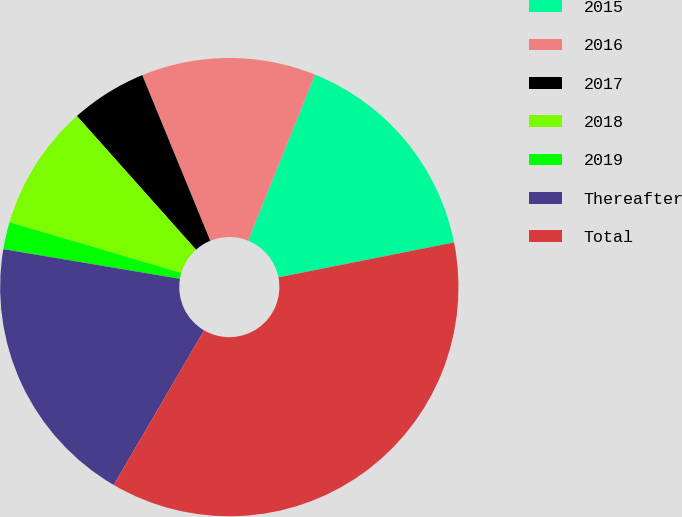Convert chart to OTSL. <chart><loc_0><loc_0><loc_500><loc_500><pie_chart><fcel>2015<fcel>2016<fcel>2017<fcel>2018<fcel>2019<fcel>Thereafter<fcel>Total<nl><fcel>15.77%<fcel>12.31%<fcel>5.38%<fcel>8.85%<fcel>1.92%<fcel>19.23%<fcel>36.54%<nl></chart> 